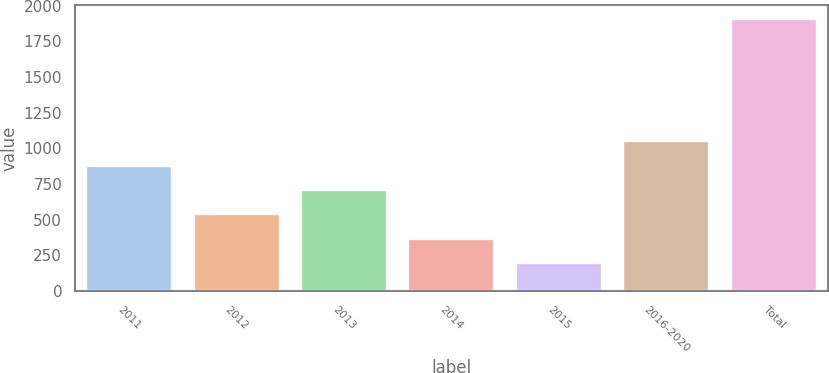Convert chart. <chart><loc_0><loc_0><loc_500><loc_500><bar_chart><fcel>2011<fcel>2012<fcel>2013<fcel>2014<fcel>2015<fcel>2016-2020<fcel>Total<nl><fcel>879.4<fcel>536.2<fcel>707.8<fcel>364.6<fcel>193<fcel>1051<fcel>1909<nl></chart> 